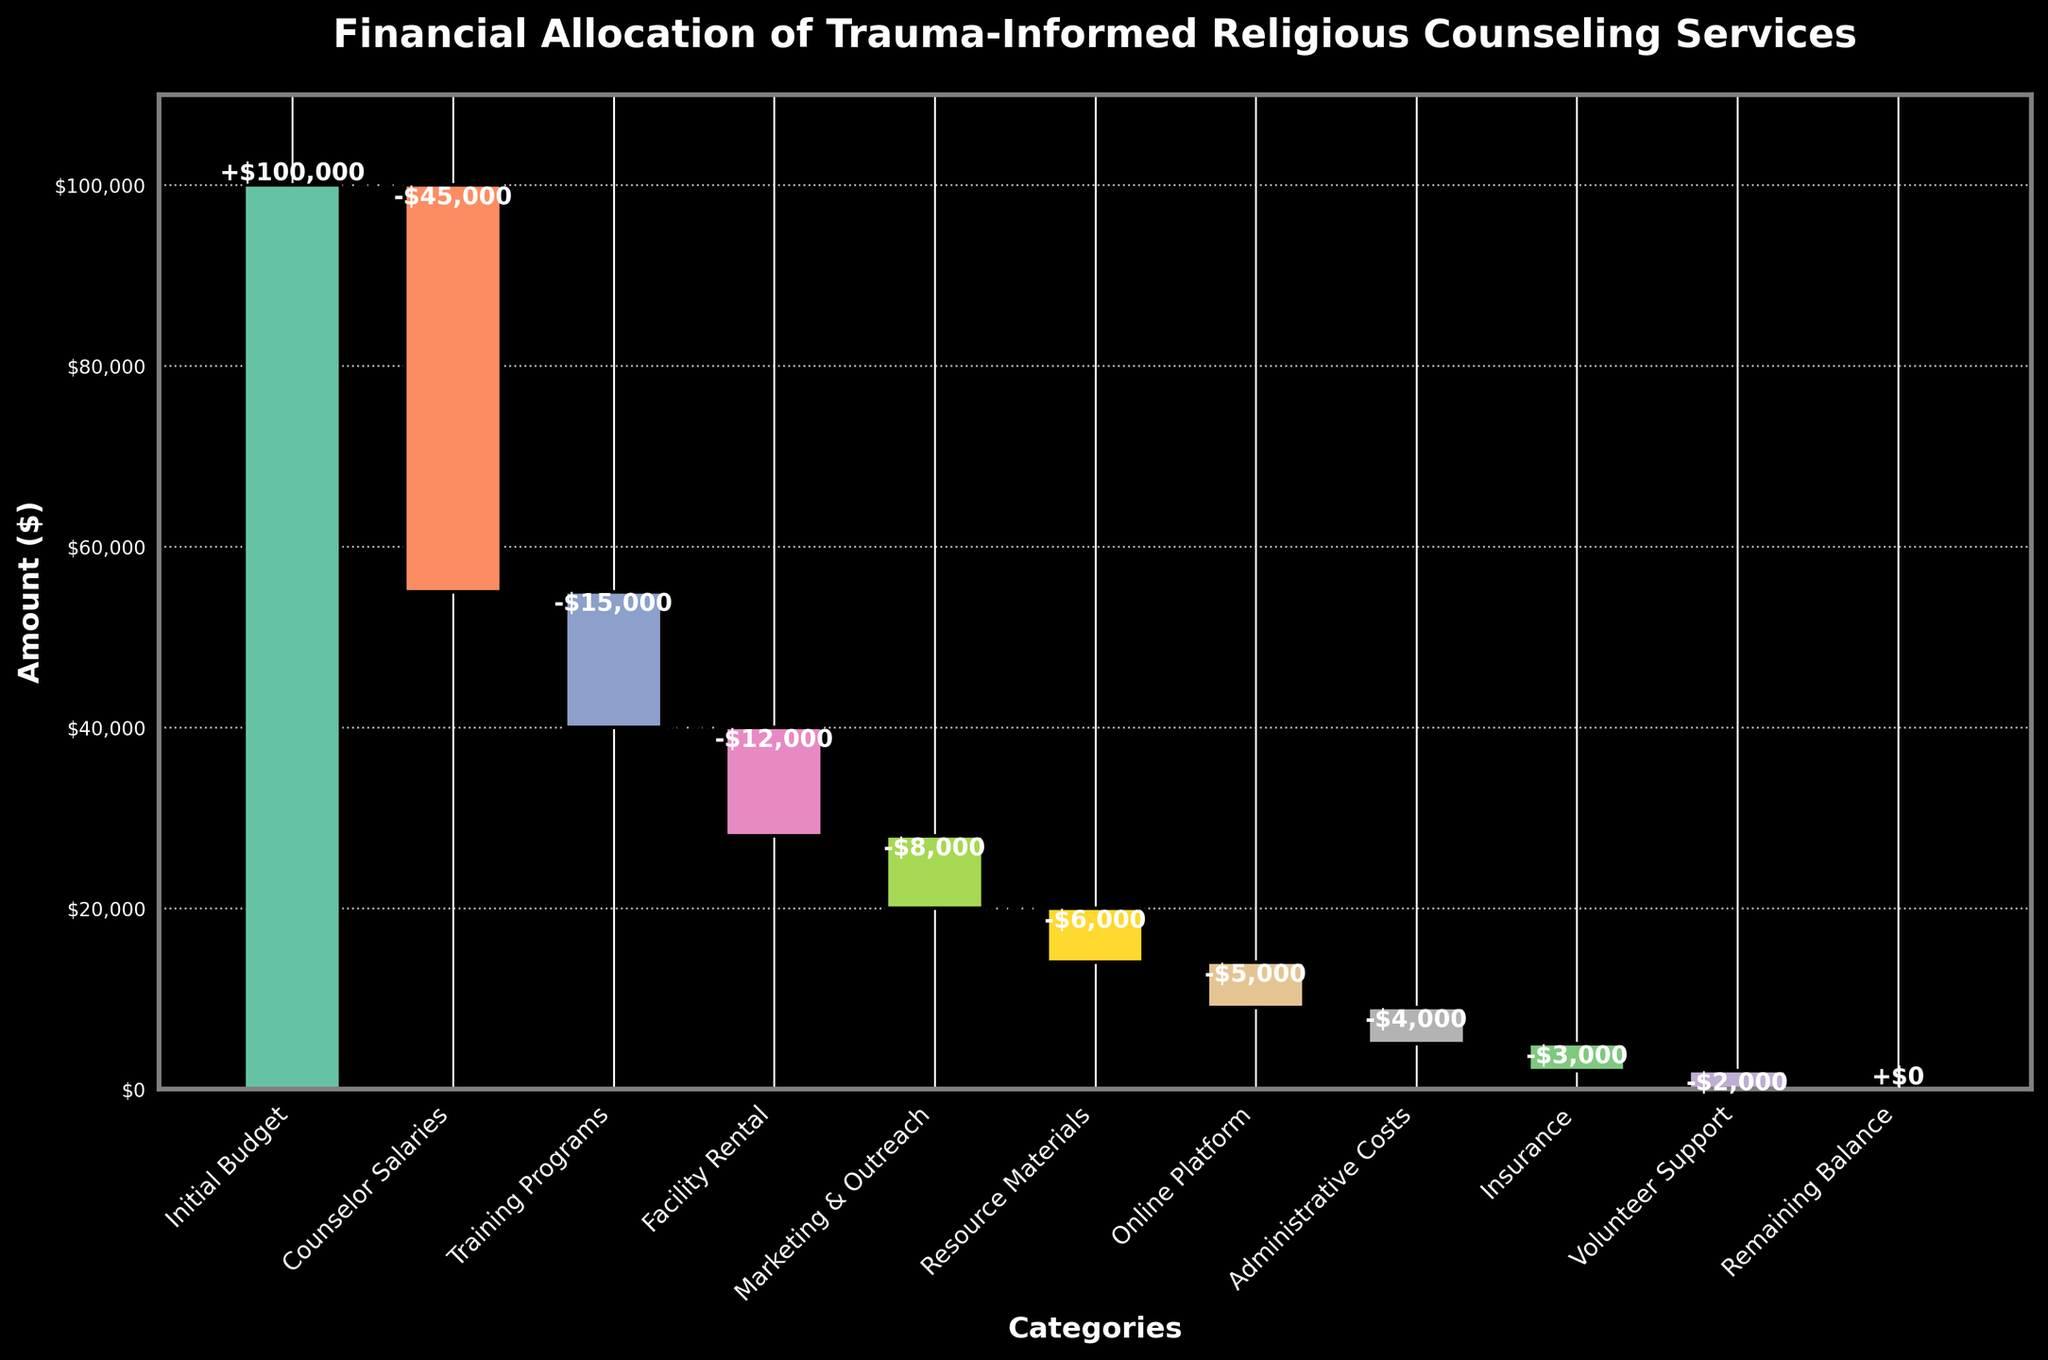What is the title of the plot? The title is usually placed at the top of the plot and provides a summary of what the plot is about. In this case, the title is "Financial Allocation of Trauma-Informed Religious Counseling Services" as shown prominently at the top.
Answer: Financial Allocation of Trauma-Informed Religious Counseling Services What is the value allocated for Counselor Salaries? The value for Counselor Salaries is represented by the bar labeled "Counselor Salaries" in the plot. According to the figure, the value is -$45,000.
Answer: -$45,000 How much of the initial budget is left after deducting Counselor Salaries and Training Programs? To find the remaining amount, first subtract Counselor Salaries (-$45,000) from the Initial Budget ($100,000), then subtract Training Programs (-$15,000) from the result. Calculation: $100,000 - $45,000 = $55,000, then $55,000 - $15,000 = $40,000.
Answer: $40,000 Which category has the smallest allocation? By comparing the lengths of the bars in the plot, the smallest allocation is the category with the shortest bar. According to the figure, Volunteer Support, with a value of -$2,000, has the smallest allocation.
Answer: Volunteer Support What is the total expenditure before the final remaining balance? Sum all the negative values listed in the categories: Counselor Salaries (-$45,000), Training Programs (-$15,000), Facility Rental (-$12,000), Marketing & Outreach (-$8,000), Resource Materials (-$6,000), Online Platform (-$5,000), Administrative Costs (-$4,000), Insurance (-$3,000), Volunteer Support (-$2,000). Calculation: -$45,000 - $15,000 - $12,000 - $8,000 - $6,000 - $5,000 - $4,000 - $3,000 - $2,000 = -$100,000.
Answer: -$100,000 How does the expenditure on Facility Rental compare to Marketing & Outreach? Look at the length of the bars for Facility Rental and Marketing & Outreach. Facility Rental is -$12,000, and Marketing & Outreach is -$8,000. Facility Rental has a higher expenditure than Marketing & Outreach by $4,000.
Answer: Facility Rental is higher by $4,000 What is the combined expenditure for Administrative Costs and Insurance? Add the values for Administrative Costs (-$4,000) and Insurance (-$3,000). Calculation: -$4,000 + (-$3,000) = -$7,000.
Answer: -$7,000 What color is used for Online Platform in the plot? Each category is signified by a unique color in the plot. The bar for Online Platform is generally assigned a color, which in this plot's styling is shown in a distinct color to differentiate from other categories.
Answer: Light brown (based on the provided color scheme) Is the remaining balance zero after all allocations? According to the plot, the figure mentions "Remaining Balance" with a value of 0, confirming that after all allocations, the remaining balance is indeed $0.
Answer: Yes How many categories of expenditures are displayed in the plot? Count the number of bars representing different expenditures in the plot. Categories include Counselor Salaries, Training Programs, Facility Rental, Marketing & Outreach, Resource Materials, Online Platform, Administrative Costs, Insurance, and Volunteer Support, totaling 9 categories plus the Initial Budget and Remaining Balance.
Answer: 9 